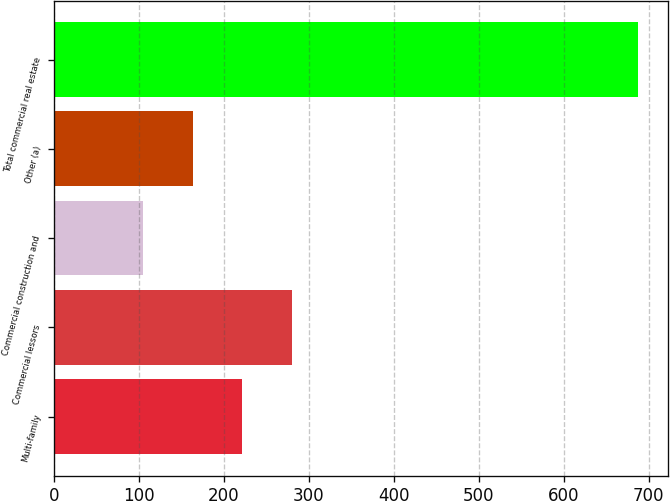<chart> <loc_0><loc_0><loc_500><loc_500><bar_chart><fcel>Multi-family<fcel>Commercial lessors<fcel>Commercial construction and<fcel>Other (a)<fcel>Total commercial real estate<nl><fcel>221.6<fcel>279.9<fcel>105<fcel>163.3<fcel>688<nl></chart> 